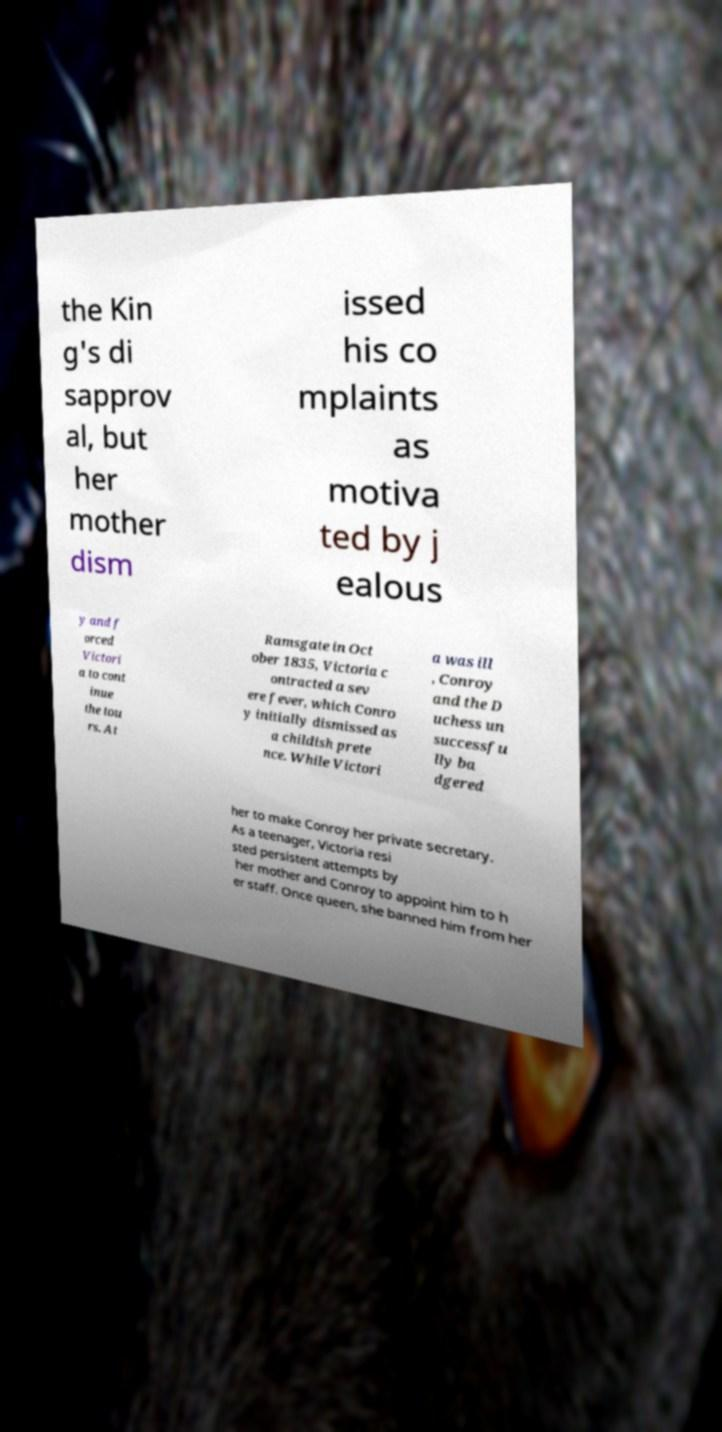Please identify and transcribe the text found in this image. the Kin g's di sapprov al, but her mother dism issed his co mplaints as motiva ted by j ealous y and f orced Victori a to cont inue the tou rs. At Ramsgate in Oct ober 1835, Victoria c ontracted a sev ere fever, which Conro y initially dismissed as a childish prete nce. While Victori a was ill , Conroy and the D uchess un successfu lly ba dgered her to make Conroy her private secretary. As a teenager, Victoria resi sted persistent attempts by her mother and Conroy to appoint him to h er staff. Once queen, she banned him from her 